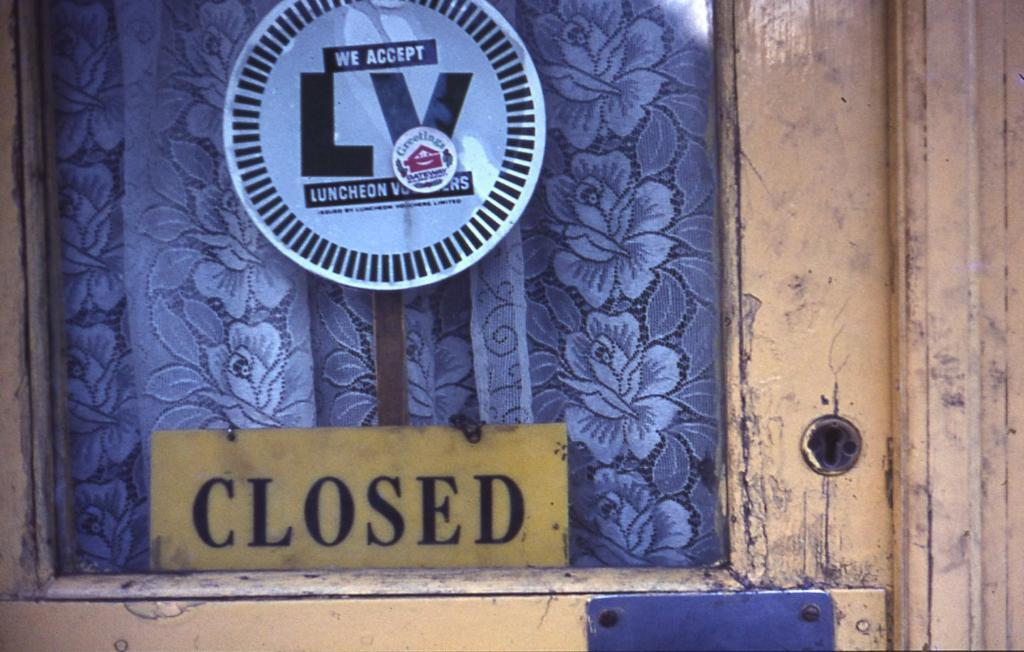<image>
Summarize the visual content of the image. A business door with a sign saying they accept Luncheon Vouchers. 